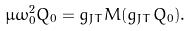<formula> <loc_0><loc_0><loc_500><loc_500>\mu \omega _ { 0 } ^ { 2 } Q _ { 0 } = g _ { J T } M ( g _ { J T } Q _ { 0 } ) .</formula> 